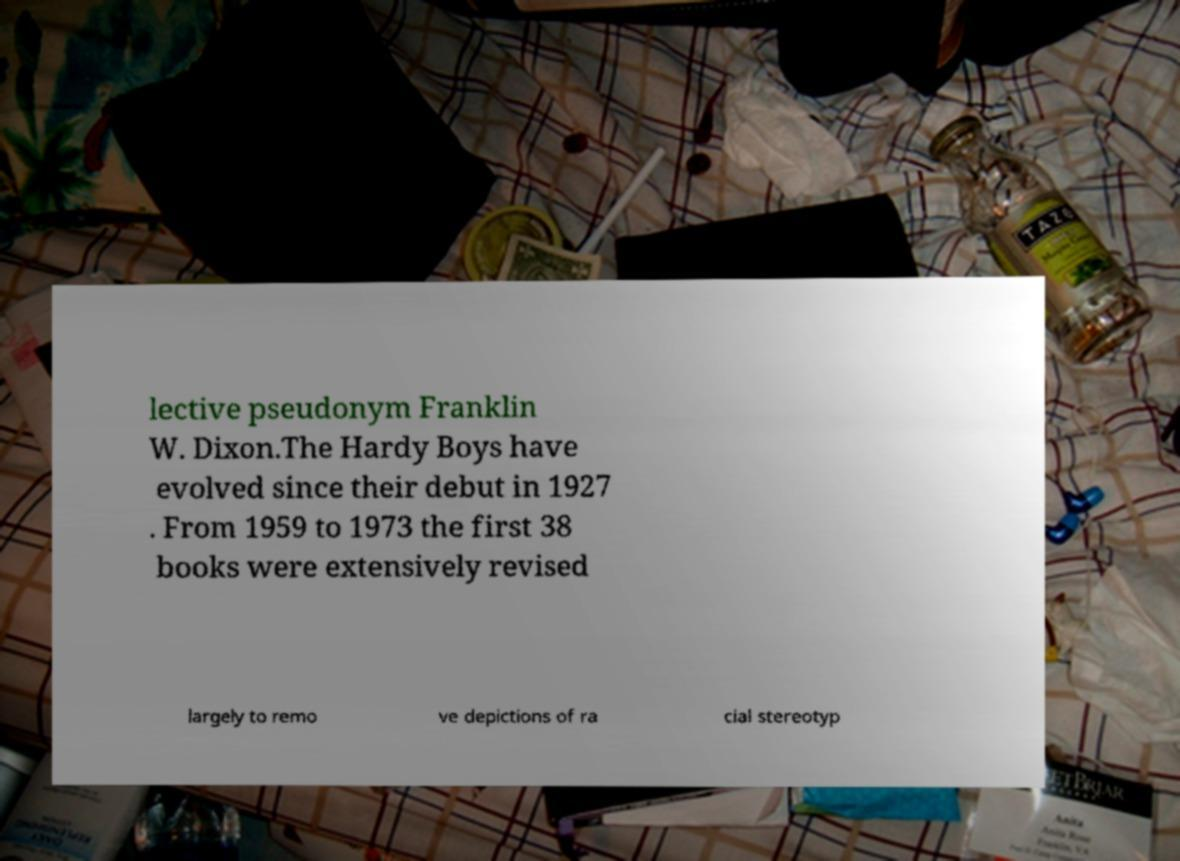Could you assist in decoding the text presented in this image and type it out clearly? lective pseudonym Franklin W. Dixon.The Hardy Boys have evolved since their debut in 1927 . From 1959 to 1973 the first 38 books were extensively revised largely to remo ve depictions of ra cial stereotyp 